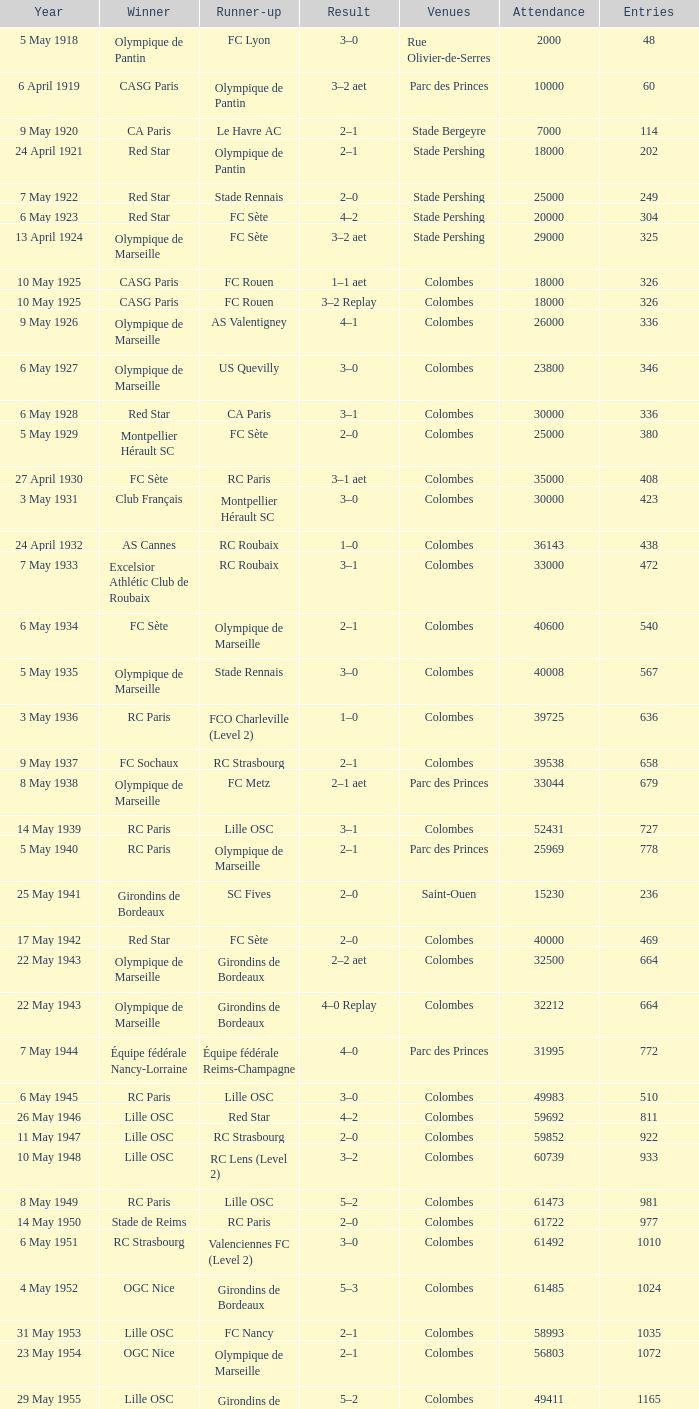What is the fewest recorded entrants against paris saint-germain? 6394.0. 